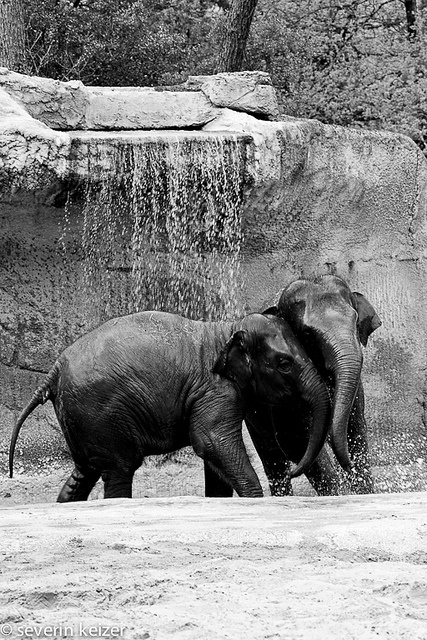Describe the objects in this image and their specific colors. I can see elephant in darkgray, black, gray, and lightgray tones and elephant in darkgray, black, gray, and lightgray tones in this image. 